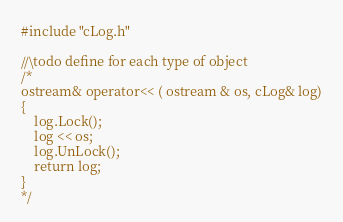<code> <loc_0><loc_0><loc_500><loc_500><_C++_>#include "cLog.h"

//\todo define for each type of object
/*
ostream& operator<< ( ostream & os, cLog& log)
{
	log.Lock();
	log << os;
	log.UnLock();
	return log;
}
*/</code> 